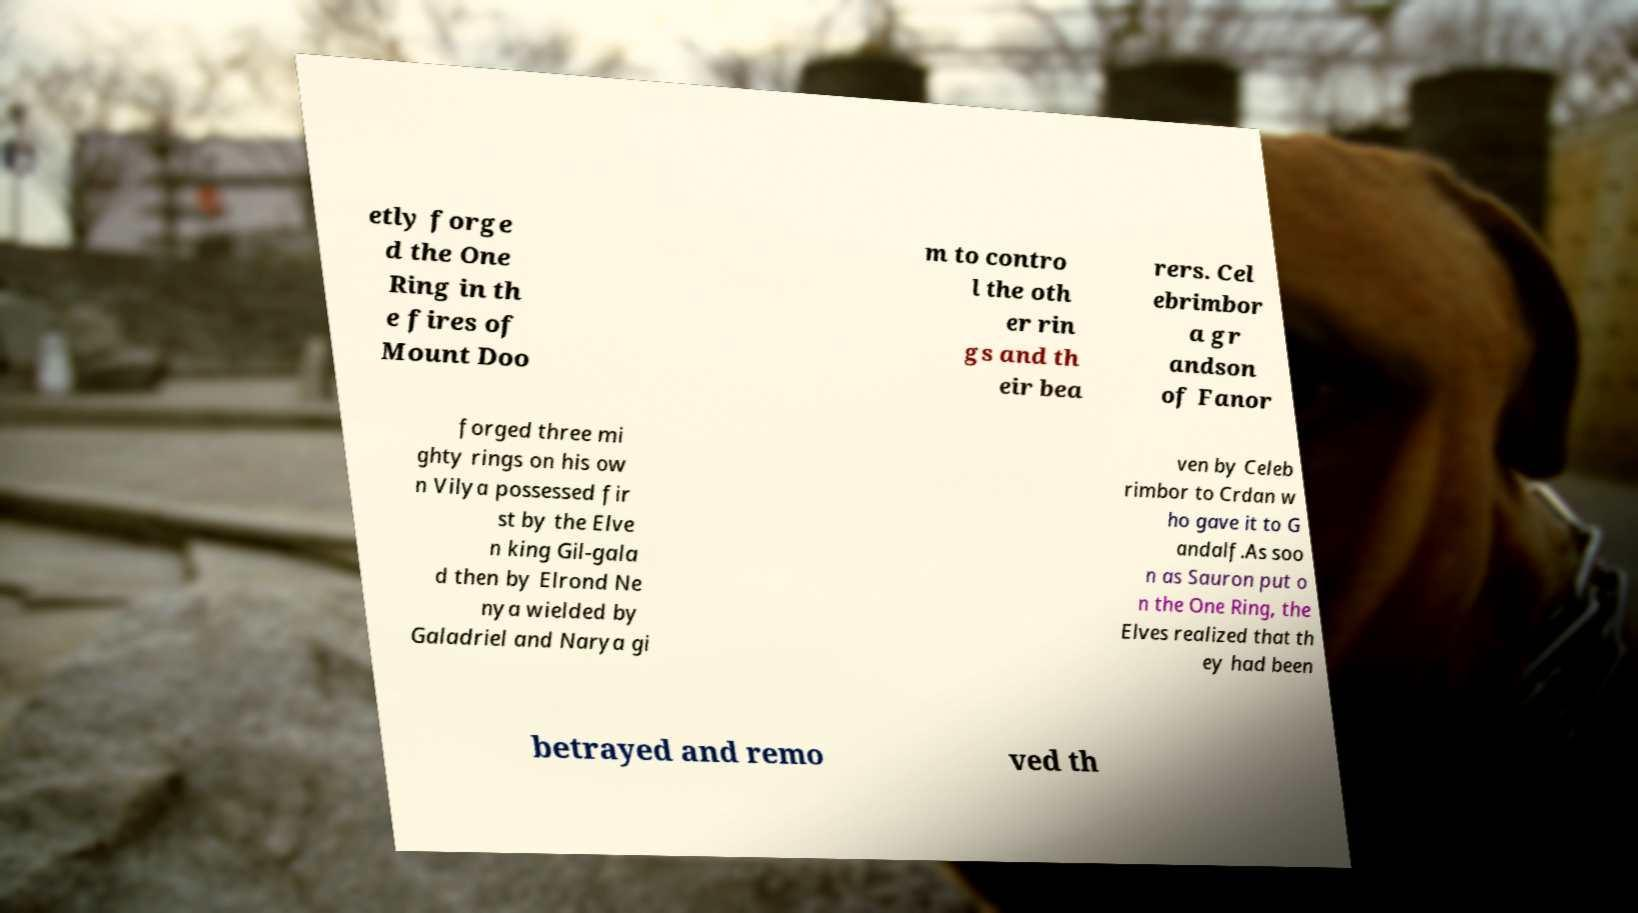There's text embedded in this image that I need extracted. Can you transcribe it verbatim? etly forge d the One Ring in th e fires of Mount Doo m to contro l the oth er rin gs and th eir bea rers. Cel ebrimbor a gr andson of Fanor forged three mi ghty rings on his ow n Vilya possessed fir st by the Elve n king Gil-gala d then by Elrond Ne nya wielded by Galadriel and Narya gi ven by Celeb rimbor to Crdan w ho gave it to G andalf.As soo n as Sauron put o n the One Ring, the Elves realized that th ey had been betrayed and remo ved th 